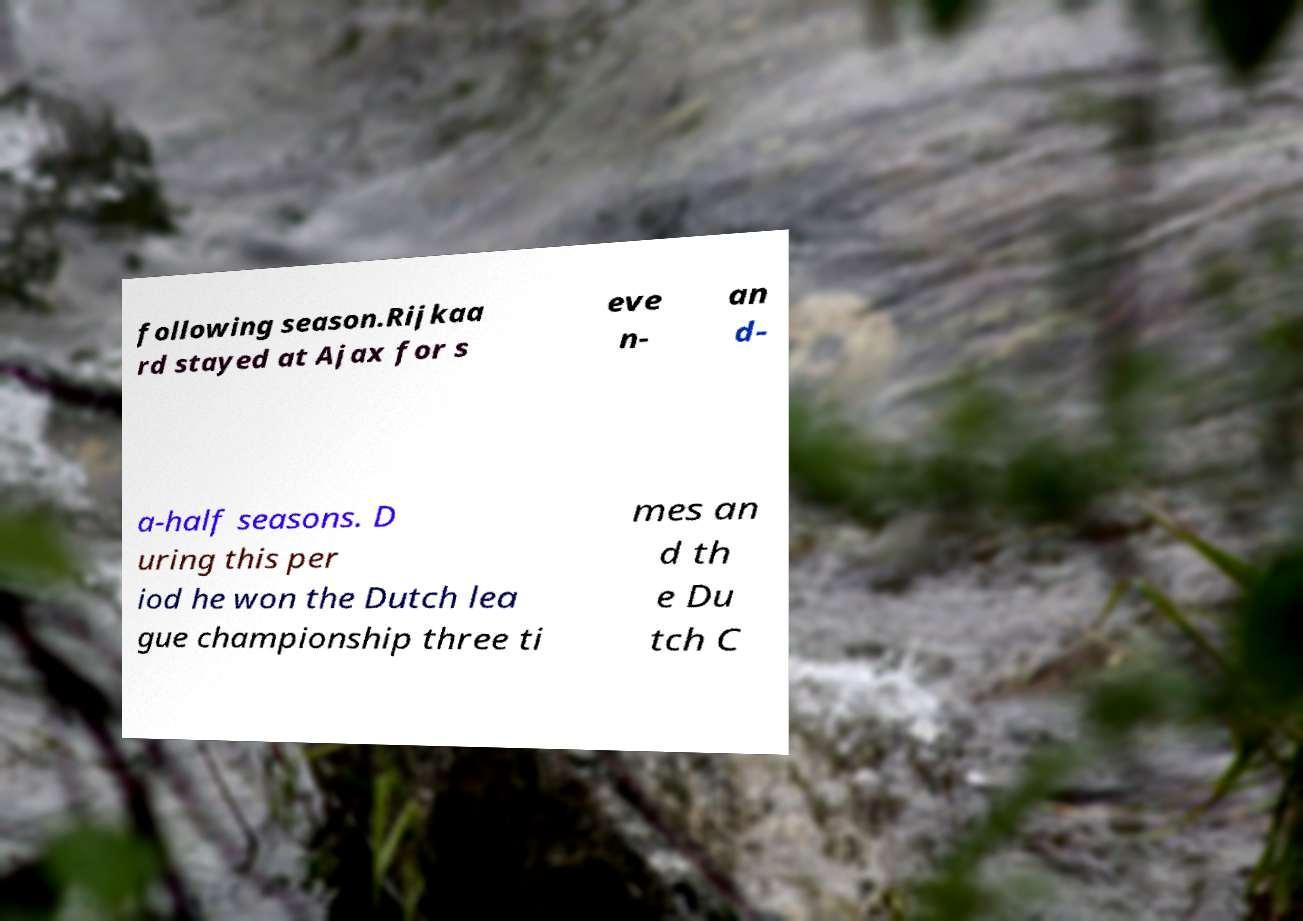Could you extract and type out the text from this image? following season.Rijkaa rd stayed at Ajax for s eve n- an d- a-half seasons. D uring this per iod he won the Dutch lea gue championship three ti mes an d th e Du tch C 